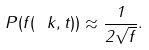<formula> <loc_0><loc_0><loc_500><loc_500>P ( f ( \ k , t ) ) \approx \frac { 1 } { 2 \sqrt { f } } .</formula> 